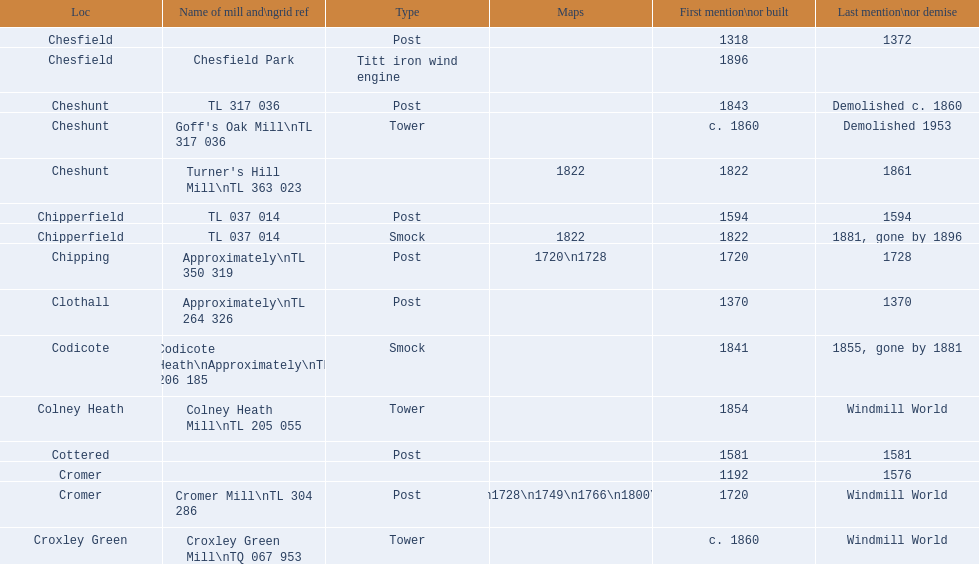How man "c" windmills have there been? 15. 